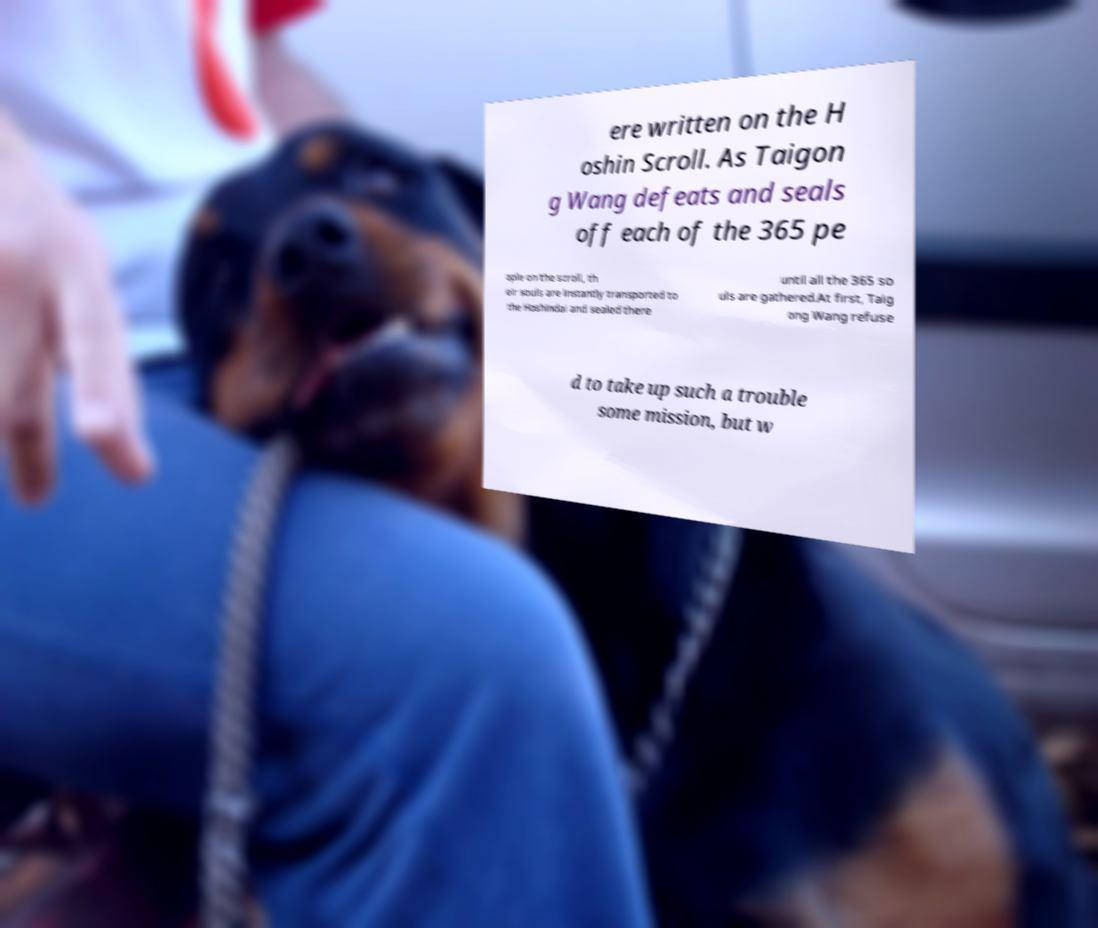Could you extract and type out the text from this image? ere written on the H oshin Scroll. As Taigon g Wang defeats and seals off each of the 365 pe ople on the scroll, th eir souls are instantly transported to the Hoshindai and sealed there until all the 365 so uls are gathered.At first, Taig ong Wang refuse d to take up such a trouble some mission, but w 